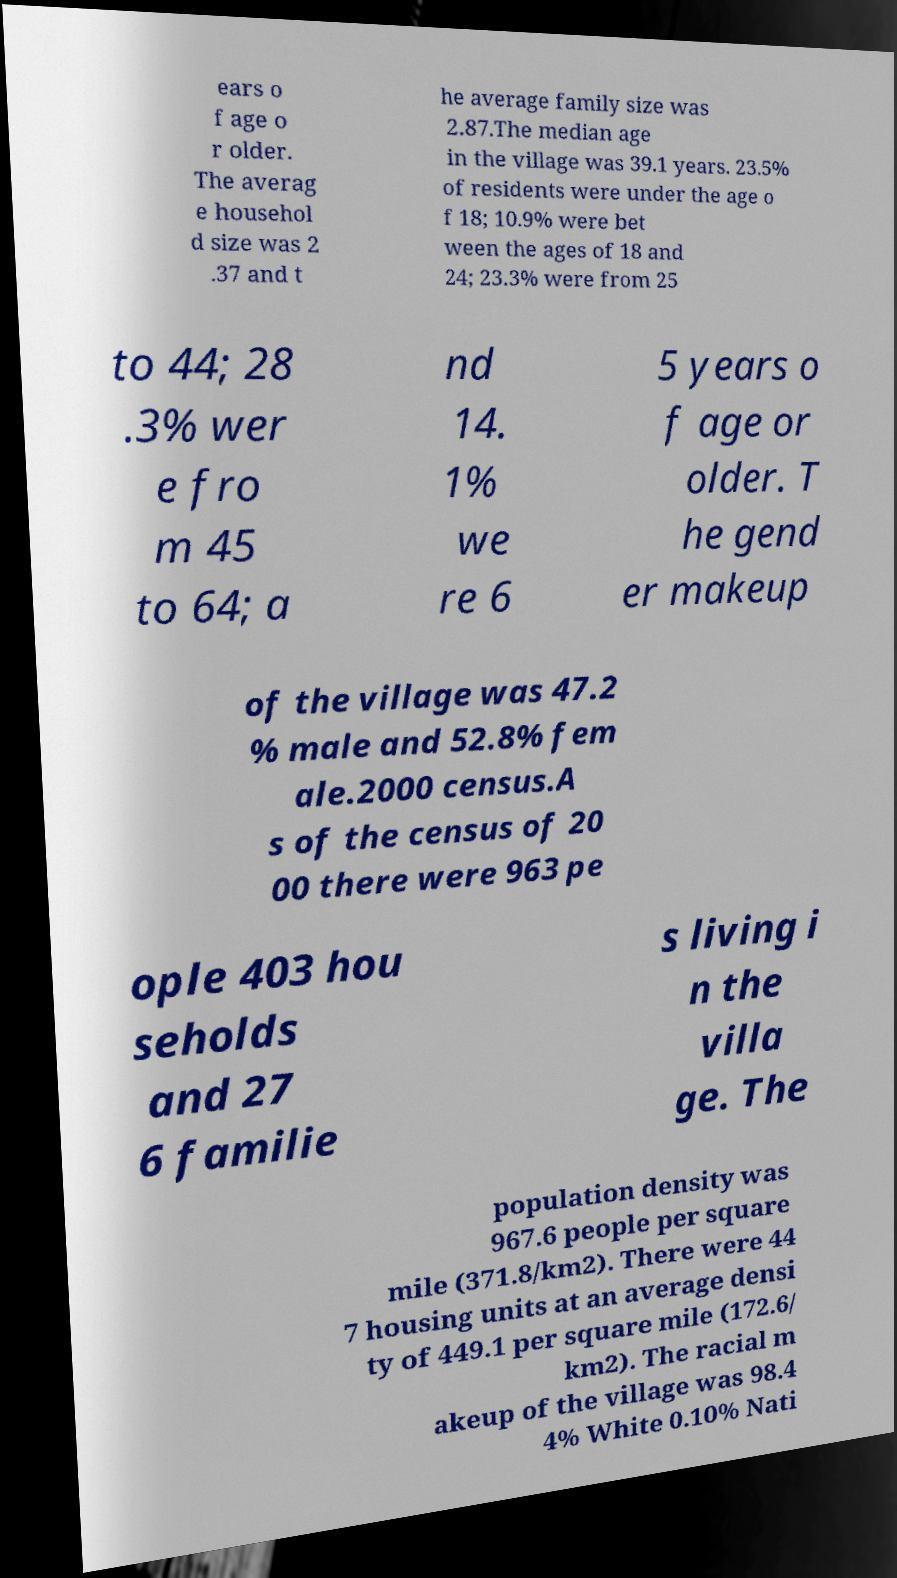Can you read and provide the text displayed in the image?This photo seems to have some interesting text. Can you extract and type it out for me? ears o f age o r older. The averag e househol d size was 2 .37 and t he average family size was 2.87.The median age in the village was 39.1 years. 23.5% of residents were under the age o f 18; 10.9% were bet ween the ages of 18 and 24; 23.3% were from 25 to 44; 28 .3% wer e fro m 45 to 64; a nd 14. 1% we re 6 5 years o f age or older. T he gend er makeup of the village was 47.2 % male and 52.8% fem ale.2000 census.A s of the census of 20 00 there were 963 pe ople 403 hou seholds and 27 6 familie s living i n the villa ge. The population density was 967.6 people per square mile (371.8/km2). There were 44 7 housing units at an average densi ty of 449.1 per square mile (172.6/ km2). The racial m akeup of the village was 98.4 4% White 0.10% Nati 